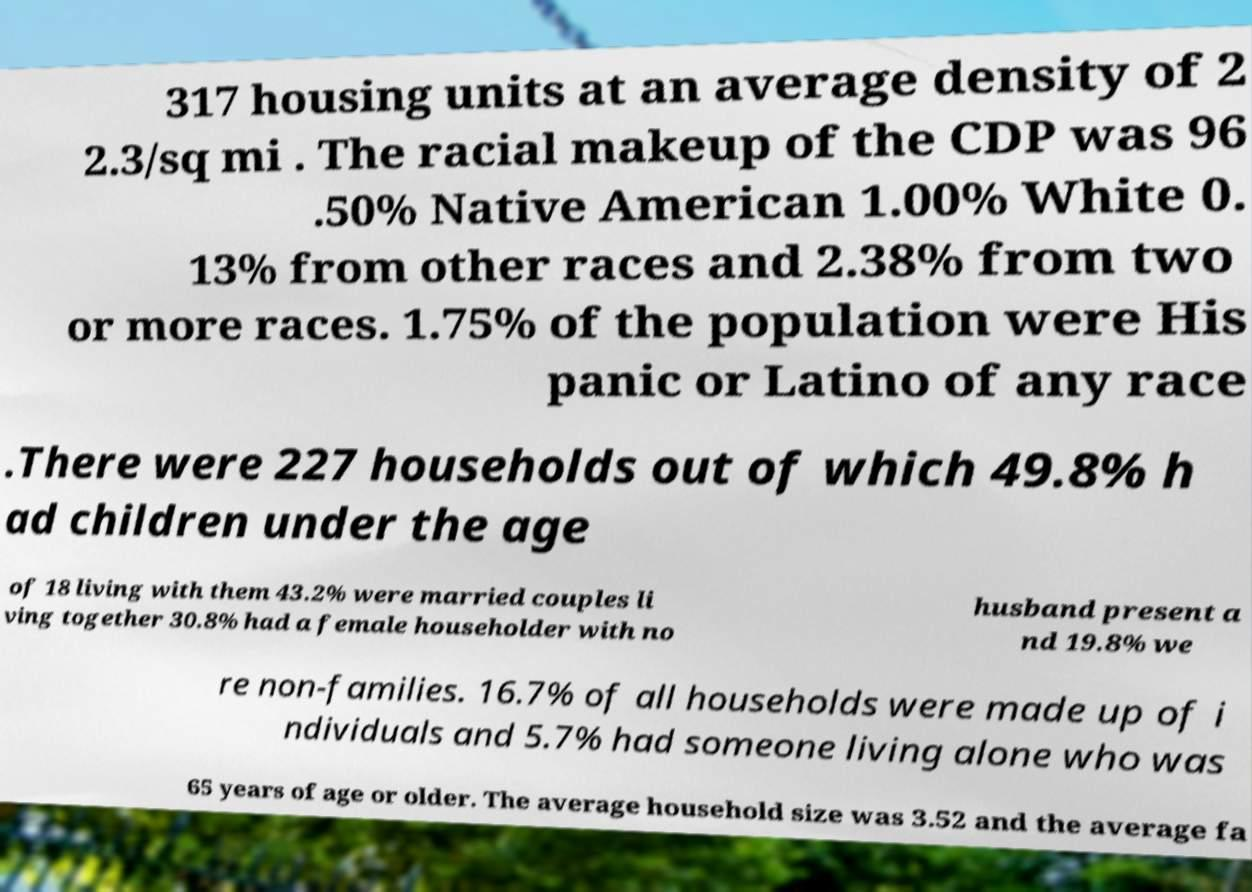Can you read and provide the text displayed in the image?This photo seems to have some interesting text. Can you extract and type it out for me? 317 housing units at an average density of 2 2.3/sq mi . The racial makeup of the CDP was 96 .50% Native American 1.00% White 0. 13% from other races and 2.38% from two or more races. 1.75% of the population were His panic or Latino of any race .There were 227 households out of which 49.8% h ad children under the age of 18 living with them 43.2% were married couples li ving together 30.8% had a female householder with no husband present a nd 19.8% we re non-families. 16.7% of all households were made up of i ndividuals and 5.7% had someone living alone who was 65 years of age or older. The average household size was 3.52 and the average fa 